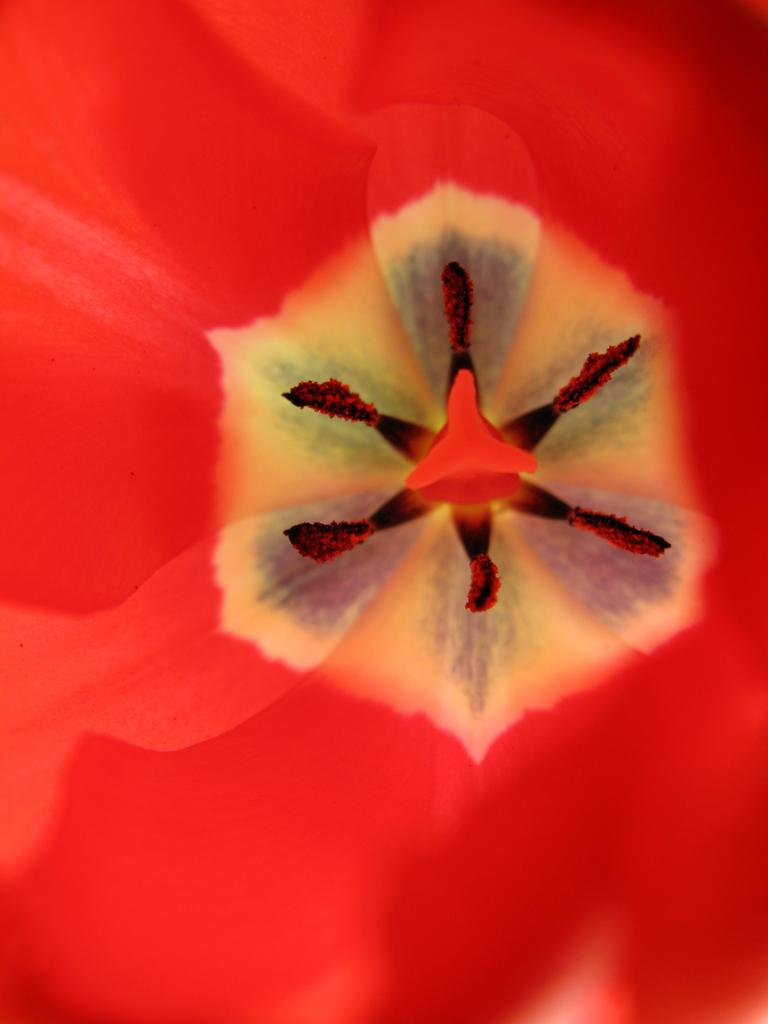What is the main subject of the image? There is a flower in the image. What type of furniture is visible in the image? There is no furniture present in the image; it only features a flower. What word is used to say good-bye to the flower in the image? There is no interaction or dialogue in the image, so there is no word used to say good-bye to the flower. 